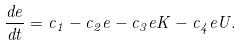Convert formula to latex. <formula><loc_0><loc_0><loc_500><loc_500>\frac { d e } { d t } = c _ { 1 } - c _ { 2 } e - c _ { 3 } e K - c _ { 4 } e U .</formula> 